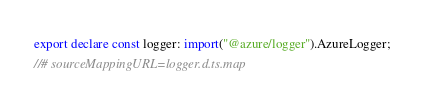Convert code to text. <code><loc_0><loc_0><loc_500><loc_500><_TypeScript_>export declare const logger: import("@azure/logger").AzureLogger;
//# sourceMappingURL=logger.d.ts.map</code> 